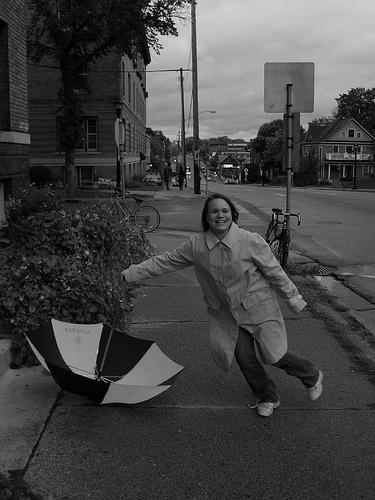What is the person jumping off of?
Concise answer only. Sidewalk. What foot is the person standing on?
Be succinct. Right. Is her umbrella being used properly?
Be succinct. No. Is the person crouching in the air?
Keep it brief. No. What is under the shoe?
Answer briefly. Sidewalk. What is the item in her hand?
Answer briefly. Umbrella. How many umbrellas are there on the sidewalk?
Quick response, please. 1. Is that a small suitcase next to her?
Answer briefly. No. What's the woman holding on her left?
Answer briefly. Umbrella. What is watering the lawn?
Keep it brief. Rain. Is it raining in this picture?
Quick response, please. No. Is it a hot day?
Short answer required. No. How many bikes are in this scene?
Give a very brief answer. 2. What is the woman holding in her hands?
Give a very brief answer. Umbrella. 